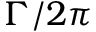<formula> <loc_0><loc_0><loc_500><loc_500>\Gamma / 2 \pi</formula> 